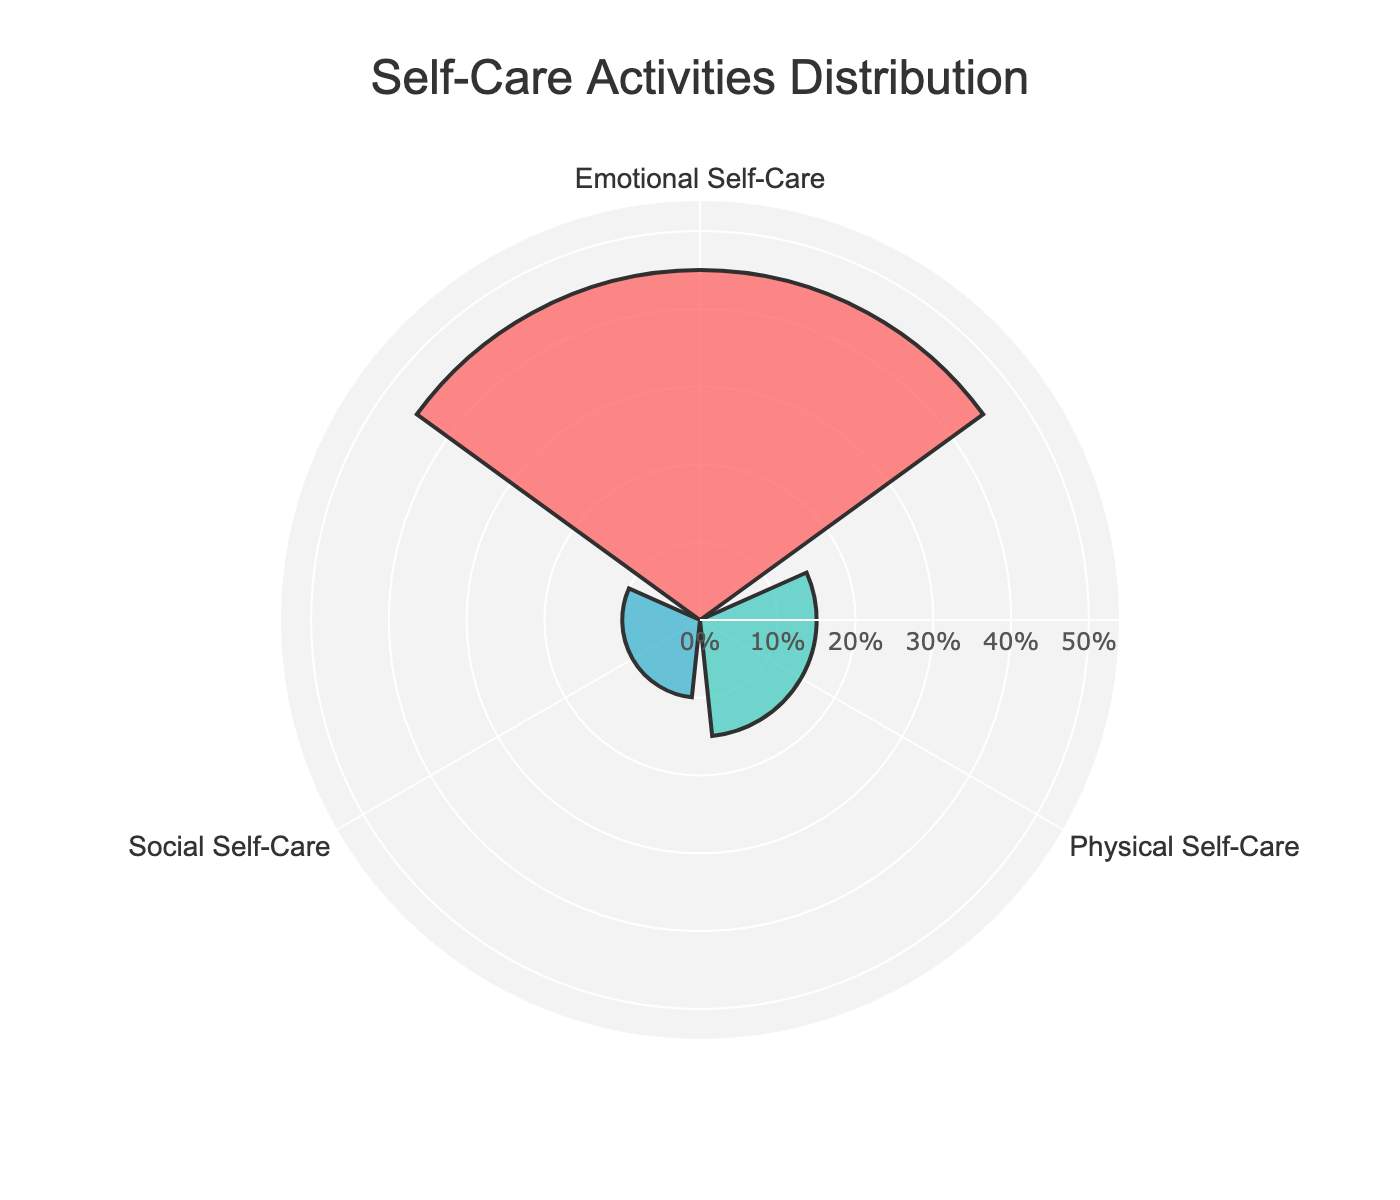What is the title of the figure? The title of the figure is located at the top and is written in large, bold font. It helps to quickly identify the subject of the plot.
Answer: Self-Care Activities Distribution How many categories of self-care activities are displayed? By looking at the axis with category labels ("Emotional Self-Care," "Physical Self-Care," and "Social Self-Care"), you can count how many different categories are there.
Answer: 3 Which category of self-care has the highest percentage? The category with the longest bar extending from the center indicates the one with the highest percentage.
Answer: Emotional Self-Care How much more percentage does Emotional Self-Care have compared to Social Self-Care? First, find the percentages for both categories. Emotional Self-Care has 45% (20% from Meditation and 25% from Counseling Sessions), and Social Self-Care has 10% (5% each from Spending Time with Friends and Support Groups). The difference is then calculated as 45% - 10%.
Answer: 35% What is the total percentage of self-care activities that involve Emotional Self-Care? You need to sum up the percentages of all activities categorized under Emotional Self-Care. Emotional Self-Care has Meditation (20%) and Counseling Sessions (25%), which sums up to 20% + 25%.
Answer: 45% Which two categories have the lowest combined percentage? Find the percentages for the Physical and Social Self-Care categories, then add the two lowest categories. Physical Self-Care is 15%, and Social Self-Care is 10%. The combined percentage is 15% + 10%.
Answer: Physical Self-Care and Social Self-Care What is the percentage range displayed in the figure? The range is determined by finding the minimum and maximum percentages on the radial axis. The minimum percentage is 0%, and the maximum percentage is 45%.
Answer: 0% to 45% What color represents the Physical Self-Care category? By reviewing the bars and their respective colors, you can identify which color is associated with Physical Self-Care.
Answer: Green How much percentage does Healthy Eating contribute to Physical Self-Care? Find the bar for physical self-care, then identify the percentage labeled or annotated on the plot.
Answer: 15% Compare the total percentage of Physical Self-Care and Social Self-Care. Which one is higher? Calculate the sum for each category. Physical Self-Care has 15%, and Social Self-Care has 10%. Compare 15% and 10%, and determine which is greater.
Answer: Physical Self-Care 